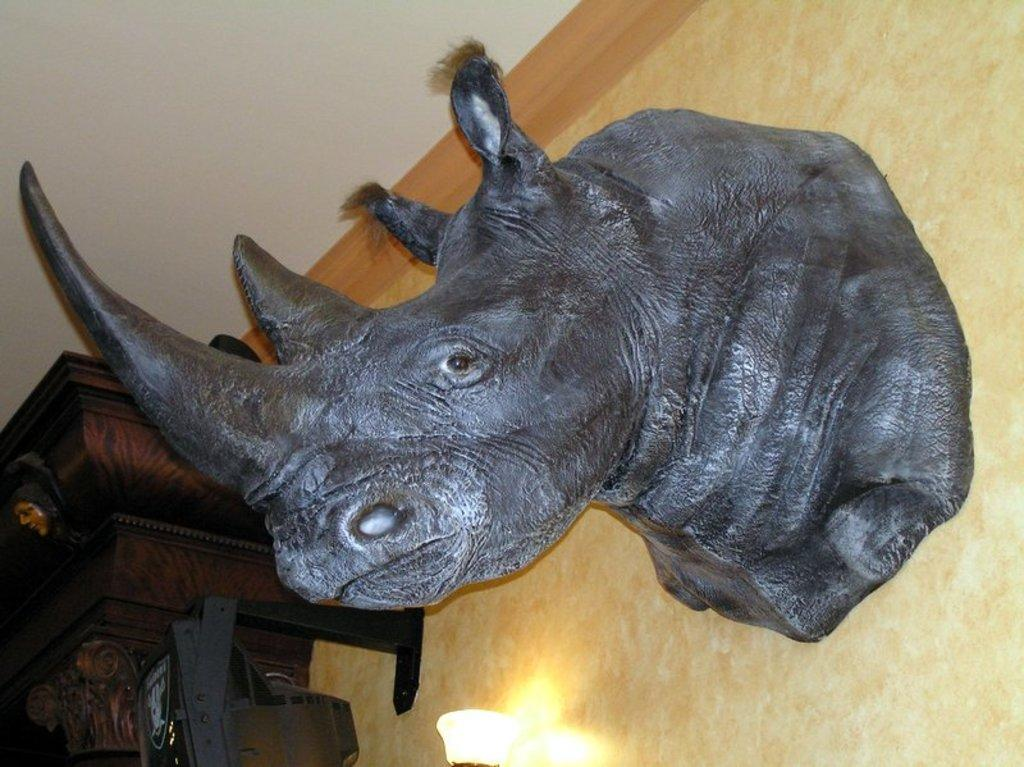What is the main subject of the image? The main subject of the image is a rhinoceros's face. What else can be seen in the image besides the rhinoceros's face? There is a sculpture on the wall in the image. Can you tell me how many people are sitting in the office in the image? There is no office or people present in the image; it features a rhinoceros's face and a sculpture on the wall. What type of airplane is flying in the background of the image? There is no airplane or background visible in the image; it only shows a rhinoceros's face and a sculpture on the wall. 